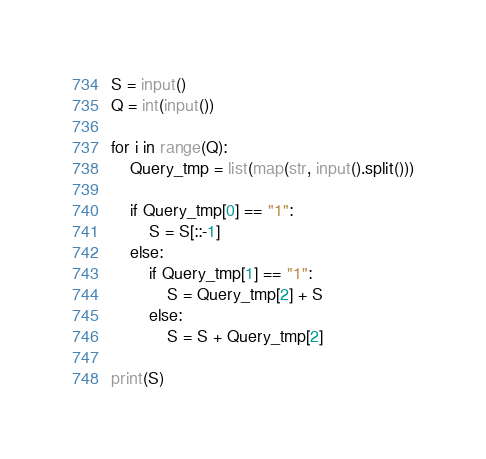<code> <loc_0><loc_0><loc_500><loc_500><_Python_>S = input()
Q = int(input())

for i in range(Q):
    Query_tmp = list(map(str, input().split()))
    
    if Query_tmp[0] == "1":
        S = S[::-1]
    else:
        if Query_tmp[1] == "1":
            S = Query_tmp[2] + S
        else:
            S = S + Query_tmp[2]

print(S)</code> 